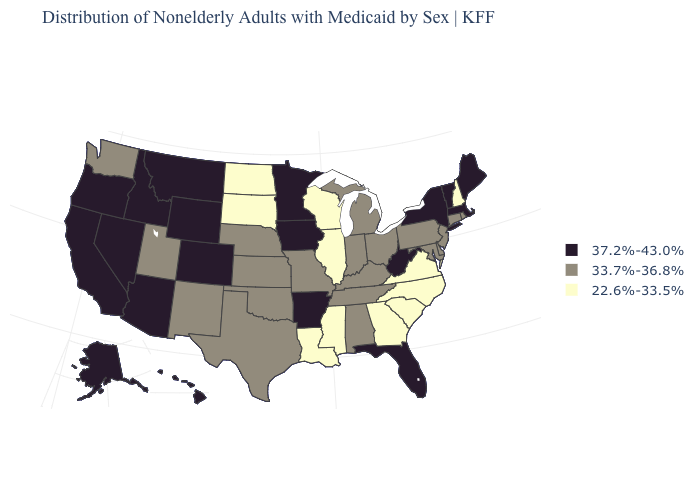Among the states that border New Hampshire , which have the highest value?
Answer briefly. Maine, Massachusetts, Vermont. What is the value of California?
Keep it brief. 37.2%-43.0%. Name the states that have a value in the range 22.6%-33.5%?
Quick response, please. Georgia, Illinois, Louisiana, Mississippi, New Hampshire, North Carolina, North Dakota, South Carolina, South Dakota, Virginia, Wisconsin. Name the states that have a value in the range 22.6%-33.5%?
Be succinct. Georgia, Illinois, Louisiana, Mississippi, New Hampshire, North Carolina, North Dakota, South Carolina, South Dakota, Virginia, Wisconsin. Name the states that have a value in the range 37.2%-43.0%?
Quick response, please. Alaska, Arizona, Arkansas, California, Colorado, Florida, Hawaii, Idaho, Iowa, Maine, Massachusetts, Minnesota, Montana, Nevada, New York, Oregon, Vermont, West Virginia, Wyoming. What is the lowest value in states that border North Dakota?
Quick response, please. 22.6%-33.5%. What is the value of Maine?
Write a very short answer. 37.2%-43.0%. Does the first symbol in the legend represent the smallest category?
Quick response, please. No. Does Indiana have the highest value in the USA?
Write a very short answer. No. Name the states that have a value in the range 22.6%-33.5%?
Keep it brief. Georgia, Illinois, Louisiana, Mississippi, New Hampshire, North Carolina, North Dakota, South Carolina, South Dakota, Virginia, Wisconsin. What is the value of Wyoming?
Concise answer only. 37.2%-43.0%. What is the value of Kentucky?
Be succinct. 33.7%-36.8%. What is the value of Texas?
Answer briefly. 33.7%-36.8%. Name the states that have a value in the range 37.2%-43.0%?
Give a very brief answer. Alaska, Arizona, Arkansas, California, Colorado, Florida, Hawaii, Idaho, Iowa, Maine, Massachusetts, Minnesota, Montana, Nevada, New York, Oregon, Vermont, West Virginia, Wyoming. Name the states that have a value in the range 22.6%-33.5%?
Concise answer only. Georgia, Illinois, Louisiana, Mississippi, New Hampshire, North Carolina, North Dakota, South Carolina, South Dakota, Virginia, Wisconsin. 